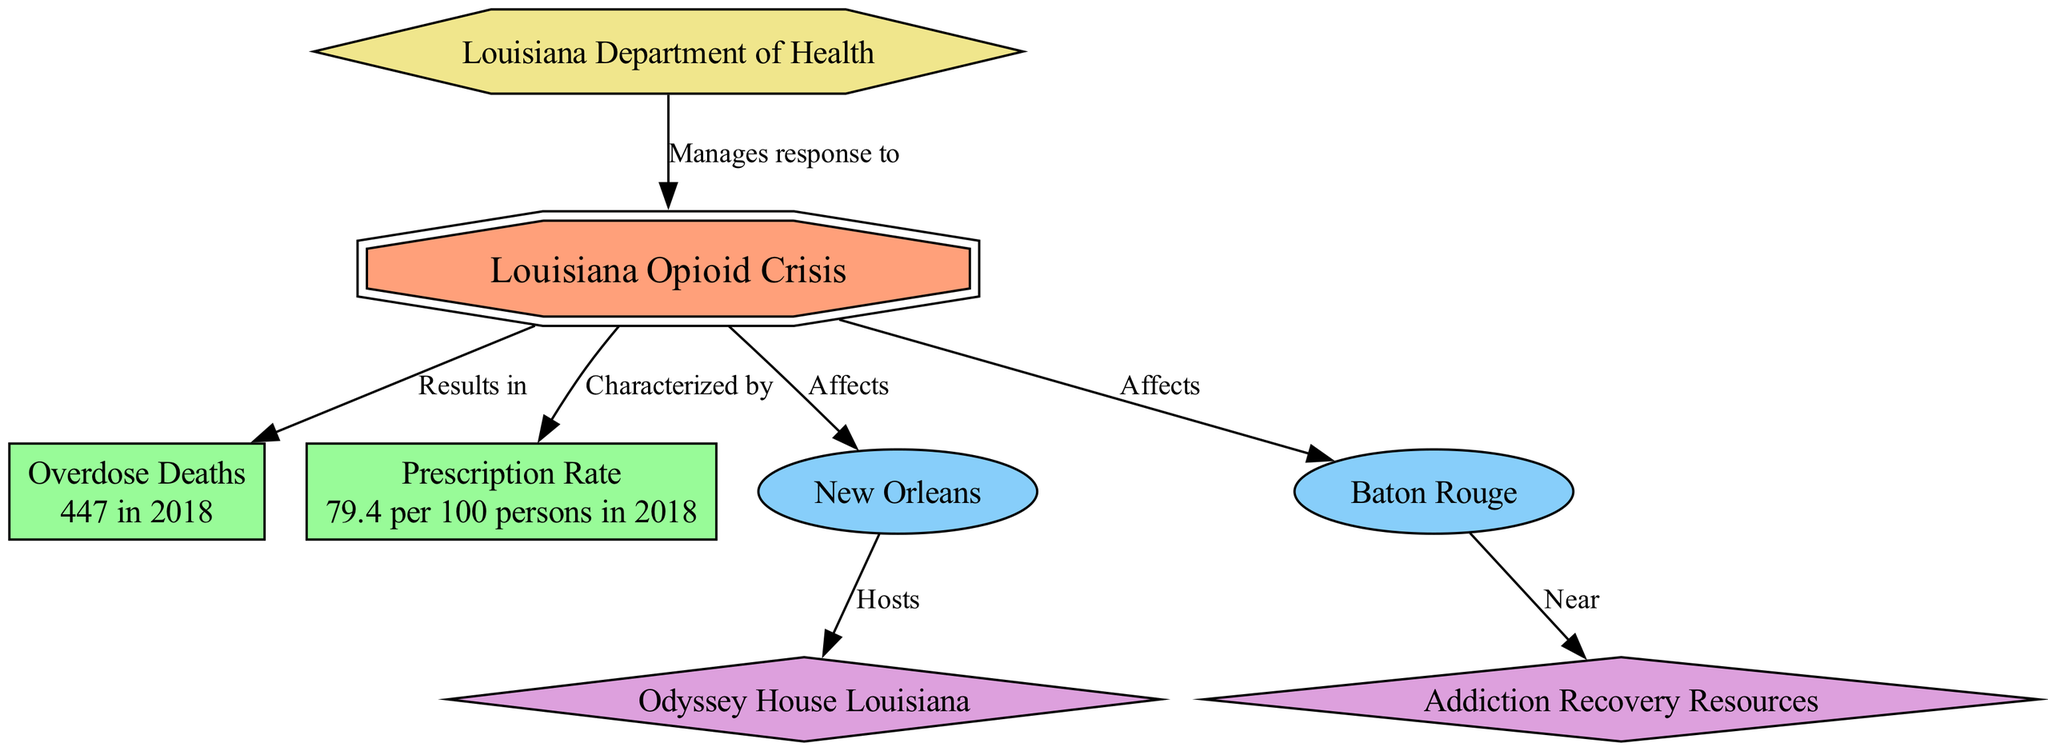What is the number of overdose deaths attributed to the opioid crisis in Louisiana in 2018? The diagram shows a node labeled "Overdose Deaths," which specifies the value "447 in 2018." This direct information answers the question clearly.
Answer: 447 in 2018 What is the prescription rate of opioids per 100 persons in Louisiana in 2018? The diagram includes a node labeled "Prescription Rate," which indicates "79.4 per 100 persons in 2018." This information directly answers the question posed.
Answer: 79.4 per 100 persons in 2018 Which two cities are identified as affected areas in the opioid crisis in Louisiana? The diagram indicates two nodes, "New Orleans" and "Baton Rouge," each connected to the central node "Louisiana Opioid Crisis" with the label "Affects." These two cities represent the affected areas.
Answer: New Orleans, Baton Rouge What treatment center is located in New Orleans? The diagram shows a node for "Odyssey House Louisiana" connected to "New Orleans" with the label "Hosts." This connection signifies that this treatment center is situated in that city.
Answer: Odyssey House Louisiana Which government entity manages the response to the opioid crisis in Louisiana? The diagram has a node labeled "Louisiana Department of Health," which connects to the central node "Louisiana Opioid Crisis" with the label "Manages response to." This indicates the role of this government entity.
Answer: Louisiana Department of Health What is the relationship between Baton Rouge and the treatment center mentioned in Metairie? The "Baton Rouge" node is connected to the "Addiction Recovery Resources" node with the label "Near." This indicates that there is a proximity relation, suggesting accessibility to treatment from Baton Rouge.
Answer: Near How many nodes are there in total within the diagram? By counting all unique nodes represented in the diagram, we can identify that there are eight nodes in total, each representing a different concept related to the opioid crisis.
Answer: 8 What does the central node represent in the context of the diagram? The central node, labeled "Louisiana Opioid Crisis," serves as the core focus of the entire diagram, encapsulating the primary issue being visualized through related statistics, affected areas, and treatment resources.
Answer: Louisiana Opioid Crisis 